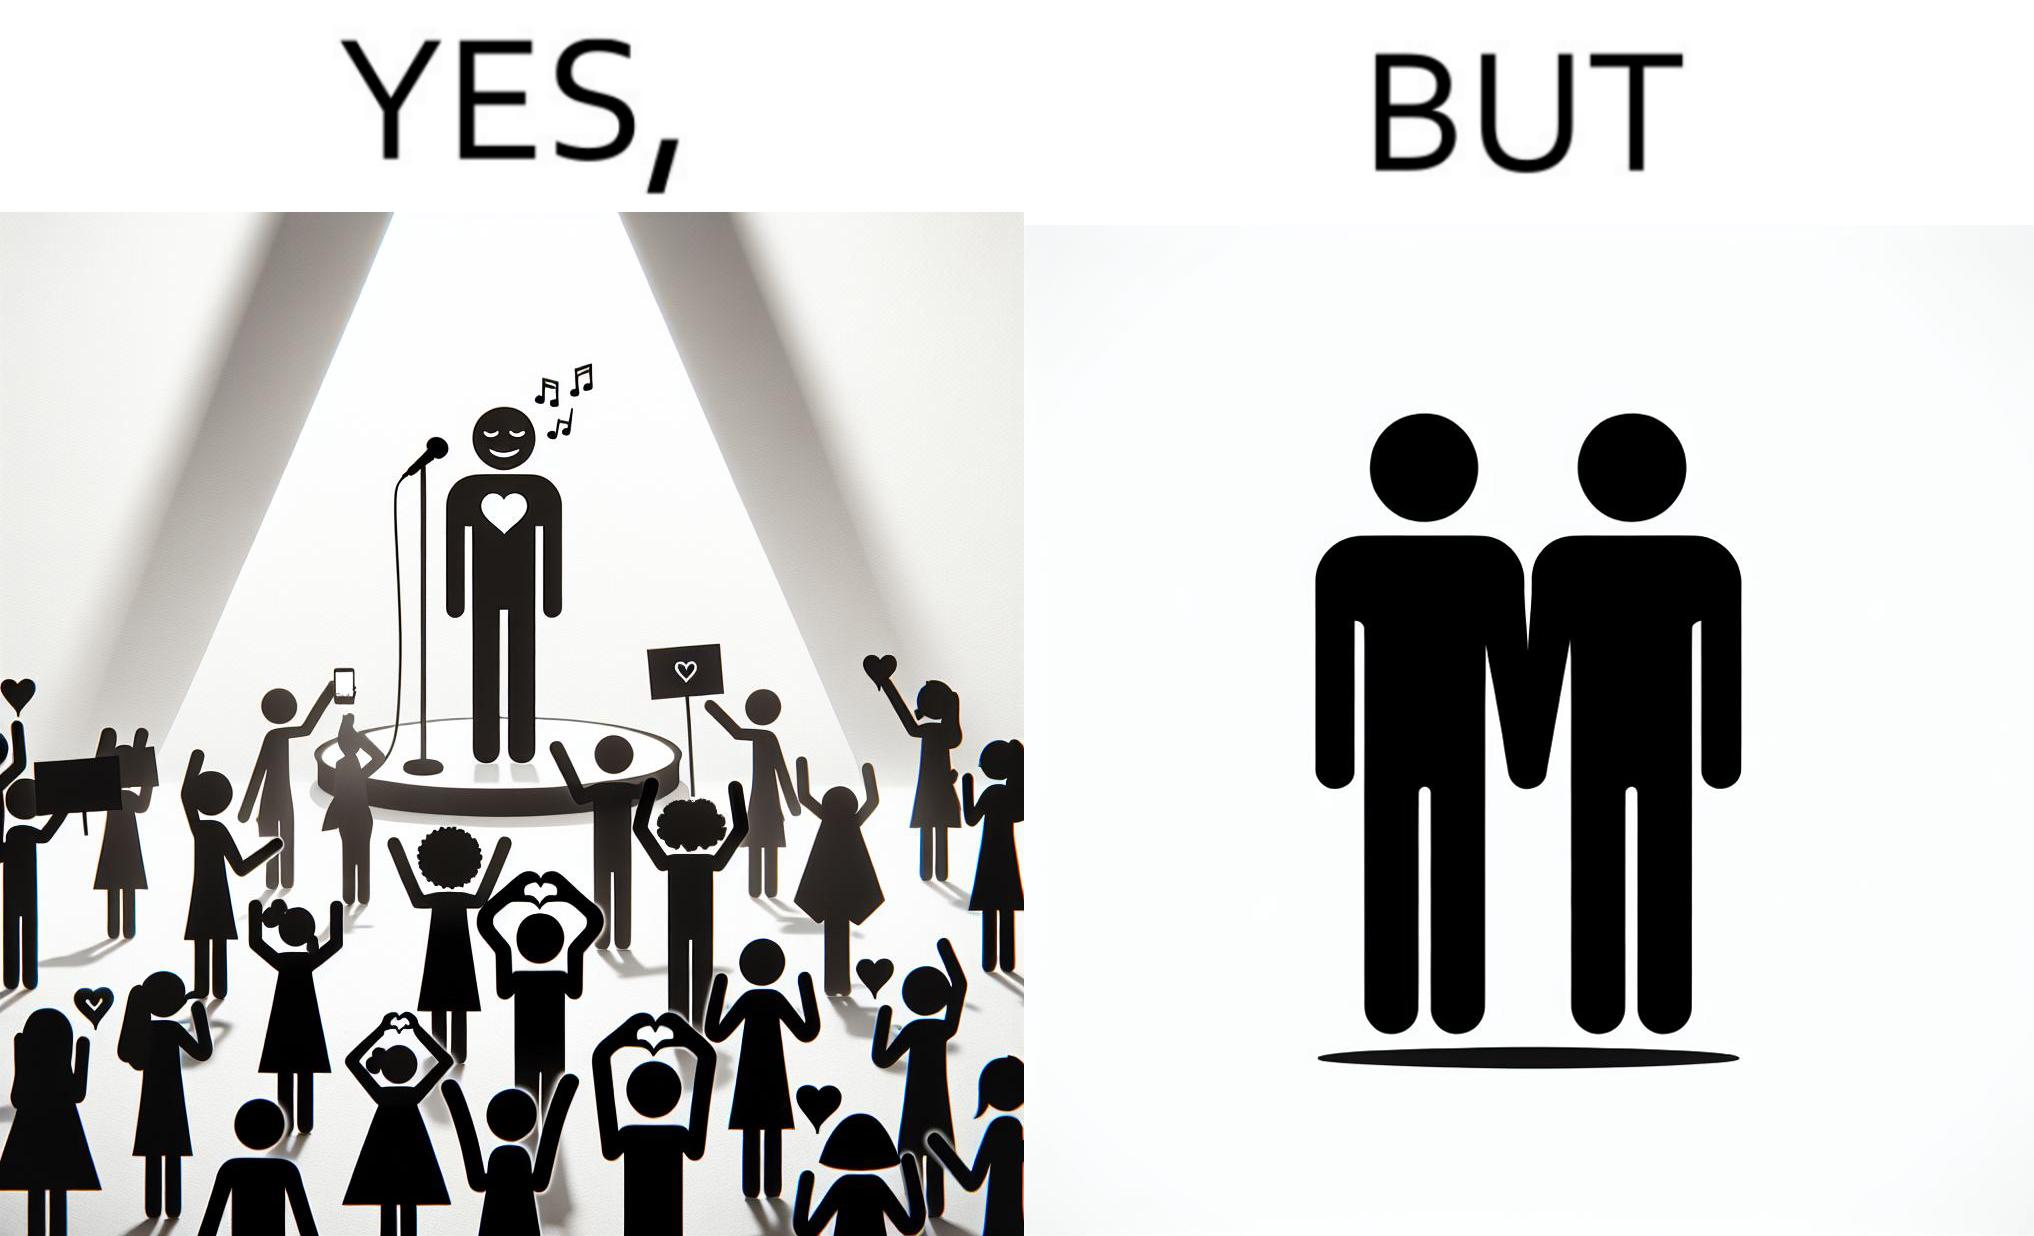Explain why this image is satirical. The image is funny because while the girls loves the man, he likes other men instead of women. 